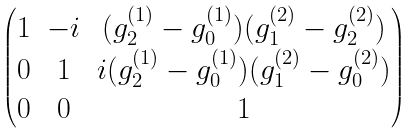Convert formula to latex. <formula><loc_0><loc_0><loc_500><loc_500>\begin{pmatrix} 1 & - i & ( g _ { 2 } ^ { ( 1 ) } - g _ { 0 } ^ { ( 1 ) } ) ( g _ { 1 } ^ { ( 2 ) } - g _ { 2 } ^ { ( 2 ) } ) \\ 0 & 1 & i ( g _ { 2 } ^ { ( 1 ) } - g _ { 0 } ^ { ( 1 ) } ) ( g _ { 1 } ^ { ( 2 ) } - g _ { 0 } ^ { ( 2 ) } ) \\ 0 & 0 & 1 \end{pmatrix}</formula> 